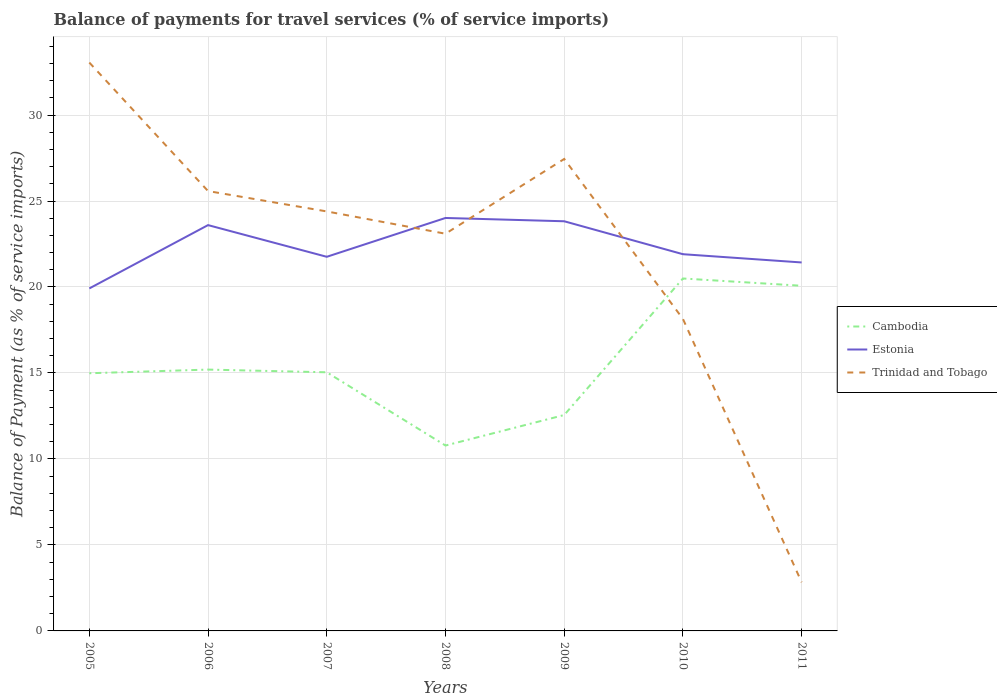Is the number of lines equal to the number of legend labels?
Make the answer very short. Yes. Across all years, what is the maximum balance of payments for travel services in Cambodia?
Your answer should be very brief. 10.78. What is the total balance of payments for travel services in Estonia in the graph?
Give a very brief answer. 1.92. What is the difference between the highest and the second highest balance of payments for travel services in Cambodia?
Offer a terse response. 9.71. How many years are there in the graph?
Offer a terse response. 7. Are the values on the major ticks of Y-axis written in scientific E-notation?
Offer a very short reply. No. Does the graph contain any zero values?
Give a very brief answer. No. How many legend labels are there?
Give a very brief answer. 3. What is the title of the graph?
Your answer should be compact. Balance of payments for travel services (% of service imports). Does "Oman" appear as one of the legend labels in the graph?
Offer a terse response. No. What is the label or title of the X-axis?
Give a very brief answer. Years. What is the label or title of the Y-axis?
Provide a short and direct response. Balance of Payment (as % of service imports). What is the Balance of Payment (as % of service imports) in Cambodia in 2005?
Give a very brief answer. 14.98. What is the Balance of Payment (as % of service imports) in Estonia in 2005?
Your answer should be compact. 19.92. What is the Balance of Payment (as % of service imports) of Trinidad and Tobago in 2005?
Provide a short and direct response. 33.05. What is the Balance of Payment (as % of service imports) of Cambodia in 2006?
Your answer should be very brief. 15.2. What is the Balance of Payment (as % of service imports) of Estonia in 2006?
Your answer should be compact. 23.6. What is the Balance of Payment (as % of service imports) in Trinidad and Tobago in 2006?
Your answer should be compact. 25.58. What is the Balance of Payment (as % of service imports) in Cambodia in 2007?
Your answer should be compact. 15.04. What is the Balance of Payment (as % of service imports) in Estonia in 2007?
Your answer should be very brief. 21.76. What is the Balance of Payment (as % of service imports) in Trinidad and Tobago in 2007?
Your response must be concise. 24.39. What is the Balance of Payment (as % of service imports) in Cambodia in 2008?
Offer a terse response. 10.78. What is the Balance of Payment (as % of service imports) of Estonia in 2008?
Ensure brevity in your answer.  24.01. What is the Balance of Payment (as % of service imports) in Trinidad and Tobago in 2008?
Offer a terse response. 23.1. What is the Balance of Payment (as % of service imports) of Cambodia in 2009?
Make the answer very short. 12.56. What is the Balance of Payment (as % of service imports) of Estonia in 2009?
Provide a succinct answer. 23.82. What is the Balance of Payment (as % of service imports) in Trinidad and Tobago in 2009?
Your response must be concise. 27.45. What is the Balance of Payment (as % of service imports) in Cambodia in 2010?
Provide a short and direct response. 20.49. What is the Balance of Payment (as % of service imports) in Estonia in 2010?
Your answer should be very brief. 21.91. What is the Balance of Payment (as % of service imports) in Trinidad and Tobago in 2010?
Offer a terse response. 18.14. What is the Balance of Payment (as % of service imports) of Cambodia in 2011?
Provide a short and direct response. 20.07. What is the Balance of Payment (as % of service imports) of Estonia in 2011?
Provide a short and direct response. 21.43. What is the Balance of Payment (as % of service imports) of Trinidad and Tobago in 2011?
Make the answer very short. 2.83. Across all years, what is the maximum Balance of Payment (as % of service imports) in Cambodia?
Offer a terse response. 20.49. Across all years, what is the maximum Balance of Payment (as % of service imports) of Estonia?
Your answer should be compact. 24.01. Across all years, what is the maximum Balance of Payment (as % of service imports) in Trinidad and Tobago?
Your answer should be compact. 33.05. Across all years, what is the minimum Balance of Payment (as % of service imports) of Cambodia?
Provide a succinct answer. 10.78. Across all years, what is the minimum Balance of Payment (as % of service imports) in Estonia?
Give a very brief answer. 19.92. Across all years, what is the minimum Balance of Payment (as % of service imports) of Trinidad and Tobago?
Provide a short and direct response. 2.83. What is the total Balance of Payment (as % of service imports) in Cambodia in the graph?
Provide a succinct answer. 109.13. What is the total Balance of Payment (as % of service imports) of Estonia in the graph?
Ensure brevity in your answer.  156.44. What is the total Balance of Payment (as % of service imports) in Trinidad and Tobago in the graph?
Offer a very short reply. 154.54. What is the difference between the Balance of Payment (as % of service imports) in Cambodia in 2005 and that in 2006?
Provide a succinct answer. -0.21. What is the difference between the Balance of Payment (as % of service imports) of Estonia in 2005 and that in 2006?
Ensure brevity in your answer.  -3.68. What is the difference between the Balance of Payment (as % of service imports) of Trinidad and Tobago in 2005 and that in 2006?
Your response must be concise. 7.47. What is the difference between the Balance of Payment (as % of service imports) of Cambodia in 2005 and that in 2007?
Your answer should be compact. -0.06. What is the difference between the Balance of Payment (as % of service imports) in Estonia in 2005 and that in 2007?
Offer a very short reply. -1.84. What is the difference between the Balance of Payment (as % of service imports) of Trinidad and Tobago in 2005 and that in 2007?
Provide a succinct answer. 8.66. What is the difference between the Balance of Payment (as % of service imports) in Cambodia in 2005 and that in 2008?
Your answer should be compact. 4.2. What is the difference between the Balance of Payment (as % of service imports) of Estonia in 2005 and that in 2008?
Provide a short and direct response. -4.1. What is the difference between the Balance of Payment (as % of service imports) of Trinidad and Tobago in 2005 and that in 2008?
Keep it short and to the point. 9.95. What is the difference between the Balance of Payment (as % of service imports) of Cambodia in 2005 and that in 2009?
Make the answer very short. 2.43. What is the difference between the Balance of Payment (as % of service imports) in Estonia in 2005 and that in 2009?
Provide a short and direct response. -3.91. What is the difference between the Balance of Payment (as % of service imports) of Trinidad and Tobago in 2005 and that in 2009?
Your answer should be very brief. 5.61. What is the difference between the Balance of Payment (as % of service imports) of Cambodia in 2005 and that in 2010?
Provide a short and direct response. -5.51. What is the difference between the Balance of Payment (as % of service imports) of Estonia in 2005 and that in 2010?
Keep it short and to the point. -1.99. What is the difference between the Balance of Payment (as % of service imports) of Trinidad and Tobago in 2005 and that in 2010?
Ensure brevity in your answer.  14.91. What is the difference between the Balance of Payment (as % of service imports) of Cambodia in 2005 and that in 2011?
Give a very brief answer. -5.09. What is the difference between the Balance of Payment (as % of service imports) of Estonia in 2005 and that in 2011?
Your answer should be very brief. -1.51. What is the difference between the Balance of Payment (as % of service imports) of Trinidad and Tobago in 2005 and that in 2011?
Make the answer very short. 30.22. What is the difference between the Balance of Payment (as % of service imports) in Cambodia in 2006 and that in 2007?
Ensure brevity in your answer.  0.16. What is the difference between the Balance of Payment (as % of service imports) in Estonia in 2006 and that in 2007?
Ensure brevity in your answer.  1.84. What is the difference between the Balance of Payment (as % of service imports) of Trinidad and Tobago in 2006 and that in 2007?
Provide a succinct answer. 1.18. What is the difference between the Balance of Payment (as % of service imports) in Cambodia in 2006 and that in 2008?
Your answer should be compact. 4.42. What is the difference between the Balance of Payment (as % of service imports) in Estonia in 2006 and that in 2008?
Your answer should be compact. -0.41. What is the difference between the Balance of Payment (as % of service imports) of Trinidad and Tobago in 2006 and that in 2008?
Your response must be concise. 2.48. What is the difference between the Balance of Payment (as % of service imports) in Cambodia in 2006 and that in 2009?
Provide a short and direct response. 2.64. What is the difference between the Balance of Payment (as % of service imports) of Estonia in 2006 and that in 2009?
Give a very brief answer. -0.22. What is the difference between the Balance of Payment (as % of service imports) in Trinidad and Tobago in 2006 and that in 2009?
Your answer should be very brief. -1.87. What is the difference between the Balance of Payment (as % of service imports) in Cambodia in 2006 and that in 2010?
Ensure brevity in your answer.  -5.3. What is the difference between the Balance of Payment (as % of service imports) of Estonia in 2006 and that in 2010?
Your response must be concise. 1.69. What is the difference between the Balance of Payment (as % of service imports) in Trinidad and Tobago in 2006 and that in 2010?
Your answer should be very brief. 7.43. What is the difference between the Balance of Payment (as % of service imports) of Cambodia in 2006 and that in 2011?
Ensure brevity in your answer.  -4.87. What is the difference between the Balance of Payment (as % of service imports) of Estonia in 2006 and that in 2011?
Provide a succinct answer. 2.17. What is the difference between the Balance of Payment (as % of service imports) in Trinidad and Tobago in 2006 and that in 2011?
Keep it short and to the point. 22.75. What is the difference between the Balance of Payment (as % of service imports) in Cambodia in 2007 and that in 2008?
Ensure brevity in your answer.  4.26. What is the difference between the Balance of Payment (as % of service imports) in Estonia in 2007 and that in 2008?
Your response must be concise. -2.26. What is the difference between the Balance of Payment (as % of service imports) in Trinidad and Tobago in 2007 and that in 2008?
Your answer should be compact. 1.3. What is the difference between the Balance of Payment (as % of service imports) in Cambodia in 2007 and that in 2009?
Provide a short and direct response. 2.48. What is the difference between the Balance of Payment (as % of service imports) in Estonia in 2007 and that in 2009?
Make the answer very short. -2.07. What is the difference between the Balance of Payment (as % of service imports) of Trinidad and Tobago in 2007 and that in 2009?
Your answer should be very brief. -3.05. What is the difference between the Balance of Payment (as % of service imports) of Cambodia in 2007 and that in 2010?
Offer a terse response. -5.45. What is the difference between the Balance of Payment (as % of service imports) of Estonia in 2007 and that in 2010?
Ensure brevity in your answer.  -0.15. What is the difference between the Balance of Payment (as % of service imports) of Trinidad and Tobago in 2007 and that in 2010?
Provide a succinct answer. 6.25. What is the difference between the Balance of Payment (as % of service imports) of Cambodia in 2007 and that in 2011?
Keep it short and to the point. -5.03. What is the difference between the Balance of Payment (as % of service imports) of Estonia in 2007 and that in 2011?
Make the answer very short. 0.33. What is the difference between the Balance of Payment (as % of service imports) of Trinidad and Tobago in 2007 and that in 2011?
Your response must be concise. 21.56. What is the difference between the Balance of Payment (as % of service imports) of Cambodia in 2008 and that in 2009?
Give a very brief answer. -1.77. What is the difference between the Balance of Payment (as % of service imports) of Estonia in 2008 and that in 2009?
Offer a very short reply. 0.19. What is the difference between the Balance of Payment (as % of service imports) of Trinidad and Tobago in 2008 and that in 2009?
Your answer should be compact. -4.35. What is the difference between the Balance of Payment (as % of service imports) of Cambodia in 2008 and that in 2010?
Your answer should be compact. -9.71. What is the difference between the Balance of Payment (as % of service imports) of Estonia in 2008 and that in 2010?
Give a very brief answer. 2.11. What is the difference between the Balance of Payment (as % of service imports) in Trinidad and Tobago in 2008 and that in 2010?
Provide a short and direct response. 4.95. What is the difference between the Balance of Payment (as % of service imports) of Cambodia in 2008 and that in 2011?
Your response must be concise. -9.29. What is the difference between the Balance of Payment (as % of service imports) in Estonia in 2008 and that in 2011?
Offer a terse response. 2.59. What is the difference between the Balance of Payment (as % of service imports) of Trinidad and Tobago in 2008 and that in 2011?
Provide a short and direct response. 20.27. What is the difference between the Balance of Payment (as % of service imports) in Cambodia in 2009 and that in 2010?
Your answer should be compact. -7.94. What is the difference between the Balance of Payment (as % of service imports) in Estonia in 2009 and that in 2010?
Your response must be concise. 1.92. What is the difference between the Balance of Payment (as % of service imports) of Trinidad and Tobago in 2009 and that in 2010?
Make the answer very short. 9.3. What is the difference between the Balance of Payment (as % of service imports) of Cambodia in 2009 and that in 2011?
Keep it short and to the point. -7.52. What is the difference between the Balance of Payment (as % of service imports) of Estonia in 2009 and that in 2011?
Keep it short and to the point. 2.4. What is the difference between the Balance of Payment (as % of service imports) of Trinidad and Tobago in 2009 and that in 2011?
Offer a terse response. 24.62. What is the difference between the Balance of Payment (as % of service imports) in Cambodia in 2010 and that in 2011?
Offer a very short reply. 0.42. What is the difference between the Balance of Payment (as % of service imports) in Estonia in 2010 and that in 2011?
Your response must be concise. 0.48. What is the difference between the Balance of Payment (as % of service imports) of Trinidad and Tobago in 2010 and that in 2011?
Your answer should be compact. 15.31. What is the difference between the Balance of Payment (as % of service imports) in Cambodia in 2005 and the Balance of Payment (as % of service imports) in Estonia in 2006?
Give a very brief answer. -8.61. What is the difference between the Balance of Payment (as % of service imports) in Cambodia in 2005 and the Balance of Payment (as % of service imports) in Trinidad and Tobago in 2006?
Offer a very short reply. -10.59. What is the difference between the Balance of Payment (as % of service imports) in Estonia in 2005 and the Balance of Payment (as % of service imports) in Trinidad and Tobago in 2006?
Offer a very short reply. -5.66. What is the difference between the Balance of Payment (as % of service imports) of Cambodia in 2005 and the Balance of Payment (as % of service imports) of Estonia in 2007?
Provide a short and direct response. -6.77. What is the difference between the Balance of Payment (as % of service imports) of Cambodia in 2005 and the Balance of Payment (as % of service imports) of Trinidad and Tobago in 2007?
Give a very brief answer. -9.41. What is the difference between the Balance of Payment (as % of service imports) of Estonia in 2005 and the Balance of Payment (as % of service imports) of Trinidad and Tobago in 2007?
Ensure brevity in your answer.  -4.48. What is the difference between the Balance of Payment (as % of service imports) in Cambodia in 2005 and the Balance of Payment (as % of service imports) in Estonia in 2008?
Offer a terse response. -9.03. What is the difference between the Balance of Payment (as % of service imports) of Cambodia in 2005 and the Balance of Payment (as % of service imports) of Trinidad and Tobago in 2008?
Provide a succinct answer. -8.11. What is the difference between the Balance of Payment (as % of service imports) in Estonia in 2005 and the Balance of Payment (as % of service imports) in Trinidad and Tobago in 2008?
Your response must be concise. -3.18. What is the difference between the Balance of Payment (as % of service imports) of Cambodia in 2005 and the Balance of Payment (as % of service imports) of Estonia in 2009?
Your answer should be very brief. -8.84. What is the difference between the Balance of Payment (as % of service imports) of Cambodia in 2005 and the Balance of Payment (as % of service imports) of Trinidad and Tobago in 2009?
Provide a succinct answer. -12.46. What is the difference between the Balance of Payment (as % of service imports) in Estonia in 2005 and the Balance of Payment (as % of service imports) in Trinidad and Tobago in 2009?
Provide a short and direct response. -7.53. What is the difference between the Balance of Payment (as % of service imports) of Cambodia in 2005 and the Balance of Payment (as % of service imports) of Estonia in 2010?
Keep it short and to the point. -6.92. What is the difference between the Balance of Payment (as % of service imports) in Cambodia in 2005 and the Balance of Payment (as % of service imports) in Trinidad and Tobago in 2010?
Provide a short and direct response. -3.16. What is the difference between the Balance of Payment (as % of service imports) in Estonia in 2005 and the Balance of Payment (as % of service imports) in Trinidad and Tobago in 2010?
Offer a terse response. 1.77. What is the difference between the Balance of Payment (as % of service imports) in Cambodia in 2005 and the Balance of Payment (as % of service imports) in Estonia in 2011?
Give a very brief answer. -6.44. What is the difference between the Balance of Payment (as % of service imports) of Cambodia in 2005 and the Balance of Payment (as % of service imports) of Trinidad and Tobago in 2011?
Your answer should be compact. 12.15. What is the difference between the Balance of Payment (as % of service imports) of Estonia in 2005 and the Balance of Payment (as % of service imports) of Trinidad and Tobago in 2011?
Provide a succinct answer. 17.09. What is the difference between the Balance of Payment (as % of service imports) in Cambodia in 2006 and the Balance of Payment (as % of service imports) in Estonia in 2007?
Your response must be concise. -6.56. What is the difference between the Balance of Payment (as % of service imports) in Cambodia in 2006 and the Balance of Payment (as % of service imports) in Trinidad and Tobago in 2007?
Your answer should be compact. -9.2. What is the difference between the Balance of Payment (as % of service imports) in Estonia in 2006 and the Balance of Payment (as % of service imports) in Trinidad and Tobago in 2007?
Your answer should be compact. -0.8. What is the difference between the Balance of Payment (as % of service imports) in Cambodia in 2006 and the Balance of Payment (as % of service imports) in Estonia in 2008?
Offer a very short reply. -8.82. What is the difference between the Balance of Payment (as % of service imports) in Cambodia in 2006 and the Balance of Payment (as % of service imports) in Trinidad and Tobago in 2008?
Provide a succinct answer. -7.9. What is the difference between the Balance of Payment (as % of service imports) of Estonia in 2006 and the Balance of Payment (as % of service imports) of Trinidad and Tobago in 2008?
Make the answer very short. 0.5. What is the difference between the Balance of Payment (as % of service imports) of Cambodia in 2006 and the Balance of Payment (as % of service imports) of Estonia in 2009?
Provide a succinct answer. -8.63. What is the difference between the Balance of Payment (as % of service imports) of Cambodia in 2006 and the Balance of Payment (as % of service imports) of Trinidad and Tobago in 2009?
Offer a terse response. -12.25. What is the difference between the Balance of Payment (as % of service imports) of Estonia in 2006 and the Balance of Payment (as % of service imports) of Trinidad and Tobago in 2009?
Offer a terse response. -3.85. What is the difference between the Balance of Payment (as % of service imports) in Cambodia in 2006 and the Balance of Payment (as % of service imports) in Estonia in 2010?
Provide a succinct answer. -6.71. What is the difference between the Balance of Payment (as % of service imports) of Cambodia in 2006 and the Balance of Payment (as % of service imports) of Trinidad and Tobago in 2010?
Your response must be concise. -2.95. What is the difference between the Balance of Payment (as % of service imports) in Estonia in 2006 and the Balance of Payment (as % of service imports) in Trinidad and Tobago in 2010?
Keep it short and to the point. 5.45. What is the difference between the Balance of Payment (as % of service imports) in Cambodia in 2006 and the Balance of Payment (as % of service imports) in Estonia in 2011?
Provide a short and direct response. -6.23. What is the difference between the Balance of Payment (as % of service imports) of Cambodia in 2006 and the Balance of Payment (as % of service imports) of Trinidad and Tobago in 2011?
Provide a succinct answer. 12.37. What is the difference between the Balance of Payment (as % of service imports) of Estonia in 2006 and the Balance of Payment (as % of service imports) of Trinidad and Tobago in 2011?
Provide a succinct answer. 20.77. What is the difference between the Balance of Payment (as % of service imports) of Cambodia in 2007 and the Balance of Payment (as % of service imports) of Estonia in 2008?
Give a very brief answer. -8.97. What is the difference between the Balance of Payment (as % of service imports) in Cambodia in 2007 and the Balance of Payment (as % of service imports) in Trinidad and Tobago in 2008?
Provide a succinct answer. -8.06. What is the difference between the Balance of Payment (as % of service imports) of Estonia in 2007 and the Balance of Payment (as % of service imports) of Trinidad and Tobago in 2008?
Your answer should be compact. -1.34. What is the difference between the Balance of Payment (as % of service imports) in Cambodia in 2007 and the Balance of Payment (as % of service imports) in Estonia in 2009?
Make the answer very short. -8.78. What is the difference between the Balance of Payment (as % of service imports) in Cambodia in 2007 and the Balance of Payment (as % of service imports) in Trinidad and Tobago in 2009?
Your answer should be compact. -12.41. What is the difference between the Balance of Payment (as % of service imports) in Estonia in 2007 and the Balance of Payment (as % of service imports) in Trinidad and Tobago in 2009?
Offer a very short reply. -5.69. What is the difference between the Balance of Payment (as % of service imports) in Cambodia in 2007 and the Balance of Payment (as % of service imports) in Estonia in 2010?
Ensure brevity in your answer.  -6.87. What is the difference between the Balance of Payment (as % of service imports) in Cambodia in 2007 and the Balance of Payment (as % of service imports) in Trinidad and Tobago in 2010?
Provide a short and direct response. -3.1. What is the difference between the Balance of Payment (as % of service imports) in Estonia in 2007 and the Balance of Payment (as % of service imports) in Trinidad and Tobago in 2010?
Your answer should be very brief. 3.61. What is the difference between the Balance of Payment (as % of service imports) in Cambodia in 2007 and the Balance of Payment (as % of service imports) in Estonia in 2011?
Offer a terse response. -6.39. What is the difference between the Balance of Payment (as % of service imports) of Cambodia in 2007 and the Balance of Payment (as % of service imports) of Trinidad and Tobago in 2011?
Give a very brief answer. 12.21. What is the difference between the Balance of Payment (as % of service imports) in Estonia in 2007 and the Balance of Payment (as % of service imports) in Trinidad and Tobago in 2011?
Give a very brief answer. 18.93. What is the difference between the Balance of Payment (as % of service imports) in Cambodia in 2008 and the Balance of Payment (as % of service imports) in Estonia in 2009?
Provide a succinct answer. -13.04. What is the difference between the Balance of Payment (as % of service imports) in Cambodia in 2008 and the Balance of Payment (as % of service imports) in Trinidad and Tobago in 2009?
Offer a terse response. -16.66. What is the difference between the Balance of Payment (as % of service imports) in Estonia in 2008 and the Balance of Payment (as % of service imports) in Trinidad and Tobago in 2009?
Your answer should be compact. -3.43. What is the difference between the Balance of Payment (as % of service imports) of Cambodia in 2008 and the Balance of Payment (as % of service imports) of Estonia in 2010?
Give a very brief answer. -11.13. What is the difference between the Balance of Payment (as % of service imports) of Cambodia in 2008 and the Balance of Payment (as % of service imports) of Trinidad and Tobago in 2010?
Provide a short and direct response. -7.36. What is the difference between the Balance of Payment (as % of service imports) in Estonia in 2008 and the Balance of Payment (as % of service imports) in Trinidad and Tobago in 2010?
Keep it short and to the point. 5.87. What is the difference between the Balance of Payment (as % of service imports) of Cambodia in 2008 and the Balance of Payment (as % of service imports) of Estonia in 2011?
Ensure brevity in your answer.  -10.65. What is the difference between the Balance of Payment (as % of service imports) in Cambodia in 2008 and the Balance of Payment (as % of service imports) in Trinidad and Tobago in 2011?
Give a very brief answer. 7.95. What is the difference between the Balance of Payment (as % of service imports) of Estonia in 2008 and the Balance of Payment (as % of service imports) of Trinidad and Tobago in 2011?
Give a very brief answer. 21.18. What is the difference between the Balance of Payment (as % of service imports) of Cambodia in 2009 and the Balance of Payment (as % of service imports) of Estonia in 2010?
Ensure brevity in your answer.  -9.35. What is the difference between the Balance of Payment (as % of service imports) of Cambodia in 2009 and the Balance of Payment (as % of service imports) of Trinidad and Tobago in 2010?
Keep it short and to the point. -5.59. What is the difference between the Balance of Payment (as % of service imports) in Estonia in 2009 and the Balance of Payment (as % of service imports) in Trinidad and Tobago in 2010?
Keep it short and to the point. 5.68. What is the difference between the Balance of Payment (as % of service imports) in Cambodia in 2009 and the Balance of Payment (as % of service imports) in Estonia in 2011?
Make the answer very short. -8.87. What is the difference between the Balance of Payment (as % of service imports) in Cambodia in 2009 and the Balance of Payment (as % of service imports) in Trinidad and Tobago in 2011?
Provide a succinct answer. 9.73. What is the difference between the Balance of Payment (as % of service imports) of Estonia in 2009 and the Balance of Payment (as % of service imports) of Trinidad and Tobago in 2011?
Offer a very short reply. 20.99. What is the difference between the Balance of Payment (as % of service imports) in Cambodia in 2010 and the Balance of Payment (as % of service imports) in Estonia in 2011?
Provide a short and direct response. -0.93. What is the difference between the Balance of Payment (as % of service imports) in Cambodia in 2010 and the Balance of Payment (as % of service imports) in Trinidad and Tobago in 2011?
Offer a terse response. 17.66. What is the difference between the Balance of Payment (as % of service imports) of Estonia in 2010 and the Balance of Payment (as % of service imports) of Trinidad and Tobago in 2011?
Keep it short and to the point. 19.08. What is the average Balance of Payment (as % of service imports) of Cambodia per year?
Offer a very short reply. 15.59. What is the average Balance of Payment (as % of service imports) in Estonia per year?
Your answer should be compact. 22.35. What is the average Balance of Payment (as % of service imports) in Trinidad and Tobago per year?
Offer a very short reply. 22.08. In the year 2005, what is the difference between the Balance of Payment (as % of service imports) of Cambodia and Balance of Payment (as % of service imports) of Estonia?
Keep it short and to the point. -4.93. In the year 2005, what is the difference between the Balance of Payment (as % of service imports) in Cambodia and Balance of Payment (as % of service imports) in Trinidad and Tobago?
Your answer should be very brief. -18.07. In the year 2005, what is the difference between the Balance of Payment (as % of service imports) of Estonia and Balance of Payment (as % of service imports) of Trinidad and Tobago?
Offer a very short reply. -13.13. In the year 2006, what is the difference between the Balance of Payment (as % of service imports) in Cambodia and Balance of Payment (as % of service imports) in Estonia?
Ensure brevity in your answer.  -8.4. In the year 2006, what is the difference between the Balance of Payment (as % of service imports) of Cambodia and Balance of Payment (as % of service imports) of Trinidad and Tobago?
Provide a succinct answer. -10.38. In the year 2006, what is the difference between the Balance of Payment (as % of service imports) of Estonia and Balance of Payment (as % of service imports) of Trinidad and Tobago?
Offer a very short reply. -1.98. In the year 2007, what is the difference between the Balance of Payment (as % of service imports) of Cambodia and Balance of Payment (as % of service imports) of Estonia?
Keep it short and to the point. -6.72. In the year 2007, what is the difference between the Balance of Payment (as % of service imports) in Cambodia and Balance of Payment (as % of service imports) in Trinidad and Tobago?
Ensure brevity in your answer.  -9.35. In the year 2007, what is the difference between the Balance of Payment (as % of service imports) in Estonia and Balance of Payment (as % of service imports) in Trinidad and Tobago?
Offer a terse response. -2.64. In the year 2008, what is the difference between the Balance of Payment (as % of service imports) of Cambodia and Balance of Payment (as % of service imports) of Estonia?
Offer a very short reply. -13.23. In the year 2008, what is the difference between the Balance of Payment (as % of service imports) of Cambodia and Balance of Payment (as % of service imports) of Trinidad and Tobago?
Provide a succinct answer. -12.32. In the year 2008, what is the difference between the Balance of Payment (as % of service imports) of Estonia and Balance of Payment (as % of service imports) of Trinidad and Tobago?
Make the answer very short. 0.92. In the year 2009, what is the difference between the Balance of Payment (as % of service imports) of Cambodia and Balance of Payment (as % of service imports) of Estonia?
Keep it short and to the point. -11.27. In the year 2009, what is the difference between the Balance of Payment (as % of service imports) of Cambodia and Balance of Payment (as % of service imports) of Trinidad and Tobago?
Provide a succinct answer. -14.89. In the year 2009, what is the difference between the Balance of Payment (as % of service imports) in Estonia and Balance of Payment (as % of service imports) in Trinidad and Tobago?
Keep it short and to the point. -3.62. In the year 2010, what is the difference between the Balance of Payment (as % of service imports) of Cambodia and Balance of Payment (as % of service imports) of Estonia?
Your response must be concise. -1.41. In the year 2010, what is the difference between the Balance of Payment (as % of service imports) in Cambodia and Balance of Payment (as % of service imports) in Trinidad and Tobago?
Provide a succinct answer. 2.35. In the year 2010, what is the difference between the Balance of Payment (as % of service imports) of Estonia and Balance of Payment (as % of service imports) of Trinidad and Tobago?
Offer a terse response. 3.76. In the year 2011, what is the difference between the Balance of Payment (as % of service imports) in Cambodia and Balance of Payment (as % of service imports) in Estonia?
Your answer should be very brief. -1.36. In the year 2011, what is the difference between the Balance of Payment (as % of service imports) of Cambodia and Balance of Payment (as % of service imports) of Trinidad and Tobago?
Your response must be concise. 17.24. In the year 2011, what is the difference between the Balance of Payment (as % of service imports) of Estonia and Balance of Payment (as % of service imports) of Trinidad and Tobago?
Your response must be concise. 18.6. What is the ratio of the Balance of Payment (as % of service imports) of Estonia in 2005 to that in 2006?
Your answer should be very brief. 0.84. What is the ratio of the Balance of Payment (as % of service imports) of Trinidad and Tobago in 2005 to that in 2006?
Offer a very short reply. 1.29. What is the ratio of the Balance of Payment (as % of service imports) of Estonia in 2005 to that in 2007?
Offer a very short reply. 0.92. What is the ratio of the Balance of Payment (as % of service imports) of Trinidad and Tobago in 2005 to that in 2007?
Make the answer very short. 1.35. What is the ratio of the Balance of Payment (as % of service imports) in Cambodia in 2005 to that in 2008?
Offer a very short reply. 1.39. What is the ratio of the Balance of Payment (as % of service imports) in Estonia in 2005 to that in 2008?
Offer a very short reply. 0.83. What is the ratio of the Balance of Payment (as % of service imports) in Trinidad and Tobago in 2005 to that in 2008?
Your answer should be compact. 1.43. What is the ratio of the Balance of Payment (as % of service imports) in Cambodia in 2005 to that in 2009?
Offer a terse response. 1.19. What is the ratio of the Balance of Payment (as % of service imports) in Estonia in 2005 to that in 2009?
Provide a succinct answer. 0.84. What is the ratio of the Balance of Payment (as % of service imports) of Trinidad and Tobago in 2005 to that in 2009?
Ensure brevity in your answer.  1.2. What is the ratio of the Balance of Payment (as % of service imports) of Cambodia in 2005 to that in 2010?
Your answer should be compact. 0.73. What is the ratio of the Balance of Payment (as % of service imports) of Trinidad and Tobago in 2005 to that in 2010?
Offer a terse response. 1.82. What is the ratio of the Balance of Payment (as % of service imports) of Cambodia in 2005 to that in 2011?
Keep it short and to the point. 0.75. What is the ratio of the Balance of Payment (as % of service imports) in Estonia in 2005 to that in 2011?
Provide a short and direct response. 0.93. What is the ratio of the Balance of Payment (as % of service imports) in Trinidad and Tobago in 2005 to that in 2011?
Provide a succinct answer. 11.68. What is the ratio of the Balance of Payment (as % of service imports) in Cambodia in 2006 to that in 2007?
Ensure brevity in your answer.  1.01. What is the ratio of the Balance of Payment (as % of service imports) of Estonia in 2006 to that in 2007?
Your answer should be compact. 1.08. What is the ratio of the Balance of Payment (as % of service imports) in Trinidad and Tobago in 2006 to that in 2007?
Provide a succinct answer. 1.05. What is the ratio of the Balance of Payment (as % of service imports) in Cambodia in 2006 to that in 2008?
Offer a very short reply. 1.41. What is the ratio of the Balance of Payment (as % of service imports) of Estonia in 2006 to that in 2008?
Your answer should be compact. 0.98. What is the ratio of the Balance of Payment (as % of service imports) in Trinidad and Tobago in 2006 to that in 2008?
Your response must be concise. 1.11. What is the ratio of the Balance of Payment (as % of service imports) in Cambodia in 2006 to that in 2009?
Provide a succinct answer. 1.21. What is the ratio of the Balance of Payment (as % of service imports) of Estonia in 2006 to that in 2009?
Your answer should be very brief. 0.99. What is the ratio of the Balance of Payment (as % of service imports) in Trinidad and Tobago in 2006 to that in 2009?
Keep it short and to the point. 0.93. What is the ratio of the Balance of Payment (as % of service imports) in Cambodia in 2006 to that in 2010?
Make the answer very short. 0.74. What is the ratio of the Balance of Payment (as % of service imports) of Estonia in 2006 to that in 2010?
Ensure brevity in your answer.  1.08. What is the ratio of the Balance of Payment (as % of service imports) in Trinidad and Tobago in 2006 to that in 2010?
Provide a short and direct response. 1.41. What is the ratio of the Balance of Payment (as % of service imports) in Cambodia in 2006 to that in 2011?
Keep it short and to the point. 0.76. What is the ratio of the Balance of Payment (as % of service imports) in Estonia in 2006 to that in 2011?
Your answer should be very brief. 1.1. What is the ratio of the Balance of Payment (as % of service imports) in Trinidad and Tobago in 2006 to that in 2011?
Ensure brevity in your answer.  9.04. What is the ratio of the Balance of Payment (as % of service imports) in Cambodia in 2007 to that in 2008?
Offer a terse response. 1.4. What is the ratio of the Balance of Payment (as % of service imports) of Estonia in 2007 to that in 2008?
Provide a succinct answer. 0.91. What is the ratio of the Balance of Payment (as % of service imports) in Trinidad and Tobago in 2007 to that in 2008?
Offer a very short reply. 1.06. What is the ratio of the Balance of Payment (as % of service imports) of Cambodia in 2007 to that in 2009?
Provide a short and direct response. 1.2. What is the ratio of the Balance of Payment (as % of service imports) in Estonia in 2007 to that in 2009?
Provide a short and direct response. 0.91. What is the ratio of the Balance of Payment (as % of service imports) in Trinidad and Tobago in 2007 to that in 2009?
Offer a very short reply. 0.89. What is the ratio of the Balance of Payment (as % of service imports) of Cambodia in 2007 to that in 2010?
Your answer should be compact. 0.73. What is the ratio of the Balance of Payment (as % of service imports) of Trinidad and Tobago in 2007 to that in 2010?
Make the answer very short. 1.34. What is the ratio of the Balance of Payment (as % of service imports) of Cambodia in 2007 to that in 2011?
Make the answer very short. 0.75. What is the ratio of the Balance of Payment (as % of service imports) in Estonia in 2007 to that in 2011?
Your response must be concise. 1.02. What is the ratio of the Balance of Payment (as % of service imports) of Trinidad and Tobago in 2007 to that in 2011?
Make the answer very short. 8.62. What is the ratio of the Balance of Payment (as % of service imports) of Cambodia in 2008 to that in 2009?
Keep it short and to the point. 0.86. What is the ratio of the Balance of Payment (as % of service imports) in Trinidad and Tobago in 2008 to that in 2009?
Your response must be concise. 0.84. What is the ratio of the Balance of Payment (as % of service imports) in Cambodia in 2008 to that in 2010?
Offer a very short reply. 0.53. What is the ratio of the Balance of Payment (as % of service imports) of Estonia in 2008 to that in 2010?
Offer a terse response. 1.1. What is the ratio of the Balance of Payment (as % of service imports) in Trinidad and Tobago in 2008 to that in 2010?
Your answer should be compact. 1.27. What is the ratio of the Balance of Payment (as % of service imports) of Cambodia in 2008 to that in 2011?
Your answer should be very brief. 0.54. What is the ratio of the Balance of Payment (as % of service imports) of Estonia in 2008 to that in 2011?
Provide a succinct answer. 1.12. What is the ratio of the Balance of Payment (as % of service imports) in Trinidad and Tobago in 2008 to that in 2011?
Make the answer very short. 8.16. What is the ratio of the Balance of Payment (as % of service imports) in Cambodia in 2009 to that in 2010?
Ensure brevity in your answer.  0.61. What is the ratio of the Balance of Payment (as % of service imports) of Estonia in 2009 to that in 2010?
Offer a terse response. 1.09. What is the ratio of the Balance of Payment (as % of service imports) in Trinidad and Tobago in 2009 to that in 2010?
Your answer should be compact. 1.51. What is the ratio of the Balance of Payment (as % of service imports) in Cambodia in 2009 to that in 2011?
Make the answer very short. 0.63. What is the ratio of the Balance of Payment (as % of service imports) of Estonia in 2009 to that in 2011?
Your answer should be very brief. 1.11. What is the ratio of the Balance of Payment (as % of service imports) of Trinidad and Tobago in 2009 to that in 2011?
Keep it short and to the point. 9.7. What is the ratio of the Balance of Payment (as % of service imports) in Cambodia in 2010 to that in 2011?
Ensure brevity in your answer.  1.02. What is the ratio of the Balance of Payment (as % of service imports) in Estonia in 2010 to that in 2011?
Your answer should be compact. 1.02. What is the ratio of the Balance of Payment (as % of service imports) of Trinidad and Tobago in 2010 to that in 2011?
Offer a terse response. 6.41. What is the difference between the highest and the second highest Balance of Payment (as % of service imports) in Cambodia?
Keep it short and to the point. 0.42. What is the difference between the highest and the second highest Balance of Payment (as % of service imports) in Estonia?
Make the answer very short. 0.19. What is the difference between the highest and the second highest Balance of Payment (as % of service imports) in Trinidad and Tobago?
Your answer should be compact. 5.61. What is the difference between the highest and the lowest Balance of Payment (as % of service imports) in Cambodia?
Offer a terse response. 9.71. What is the difference between the highest and the lowest Balance of Payment (as % of service imports) of Estonia?
Keep it short and to the point. 4.1. What is the difference between the highest and the lowest Balance of Payment (as % of service imports) in Trinidad and Tobago?
Offer a very short reply. 30.22. 